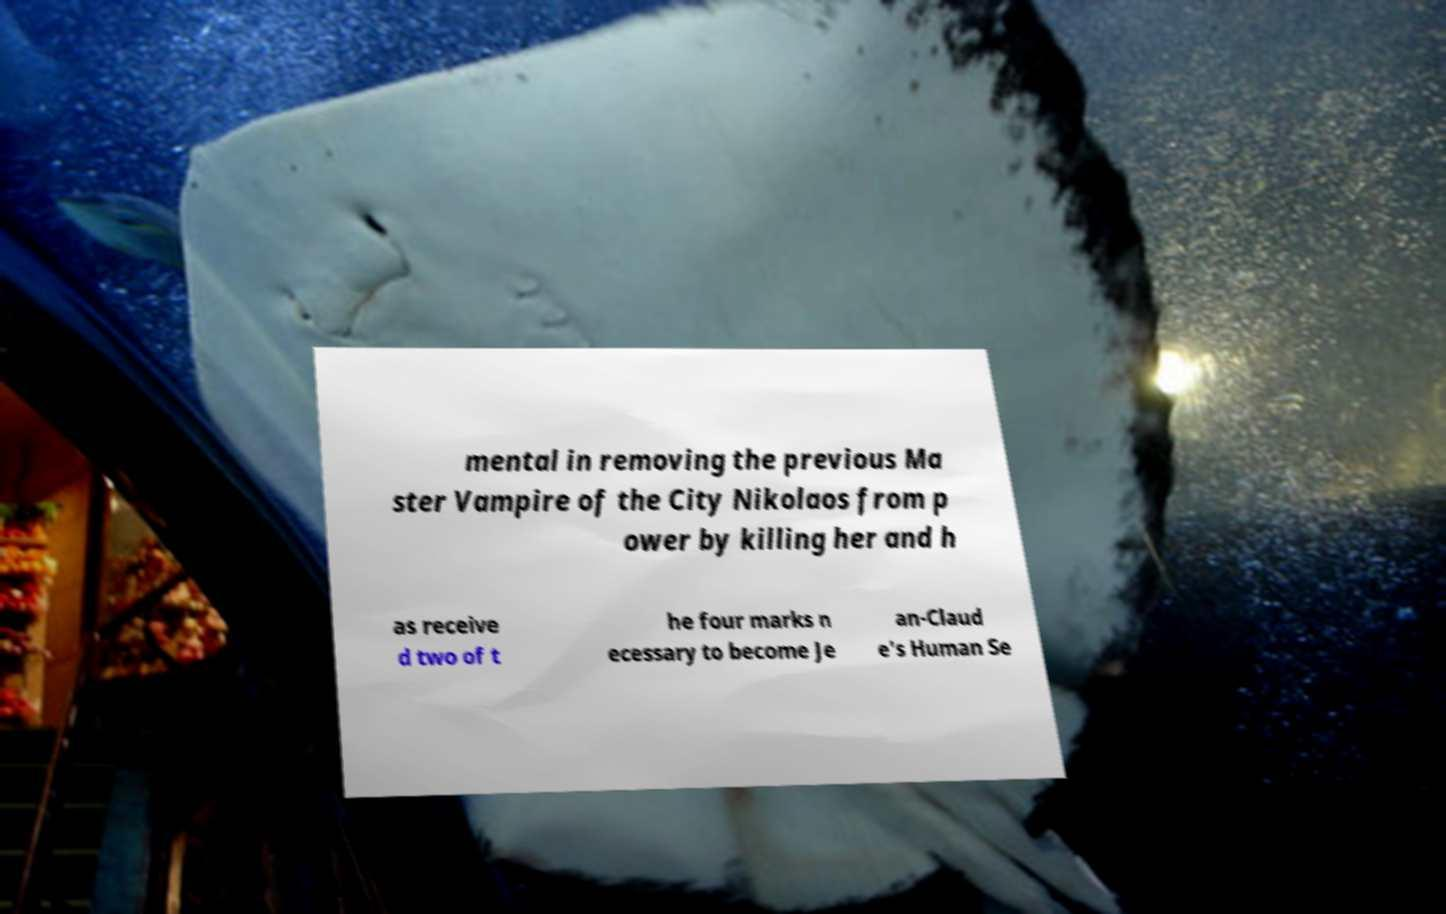Please read and relay the text visible in this image. What does it say? mental in removing the previous Ma ster Vampire of the City Nikolaos from p ower by killing her and h as receive d two of t he four marks n ecessary to become Je an-Claud e's Human Se 